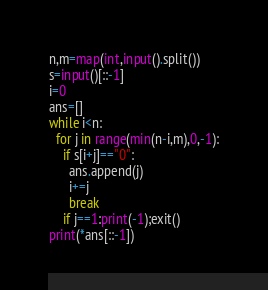Convert code to text. <code><loc_0><loc_0><loc_500><loc_500><_Python_>n,m=map(int,input().split())
s=input()[::-1]
i=0
ans=[]
while i<n:
  for j in range(min(n-i,m),0,-1):
    if s[i+j]=="0":
      ans.append(j)
      i+=j
      break
    if j==1:print(-1);exit()
print(*ans[::-1])</code> 